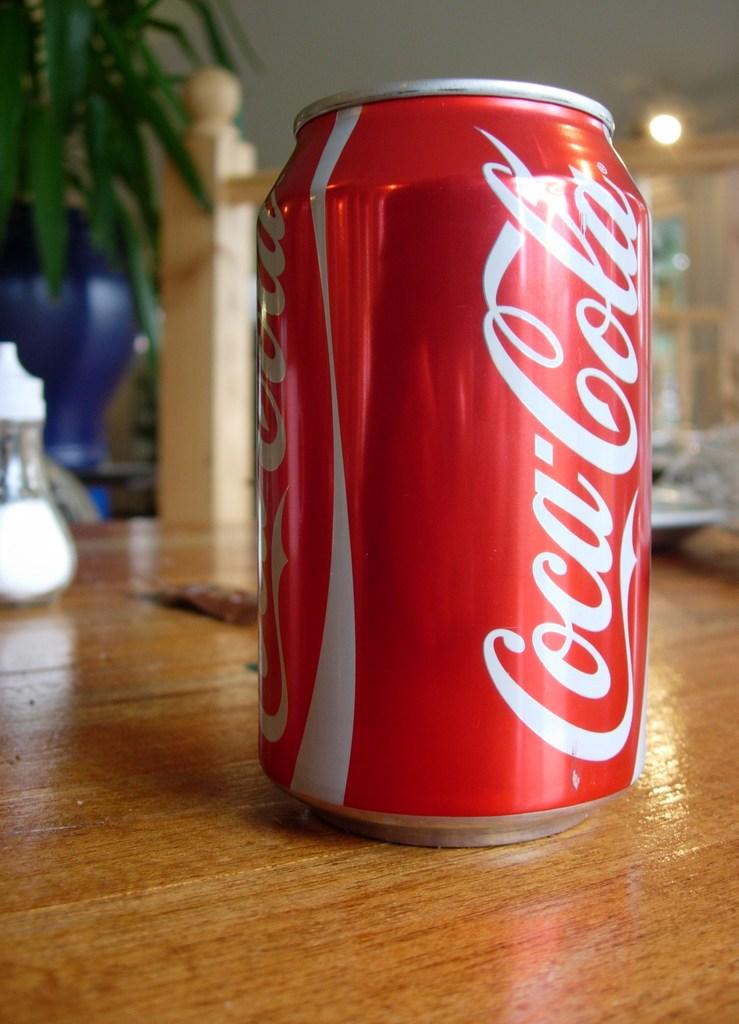What's in the can?
Your answer should be compact. Coca cola. Is this a can of pepsi?
Provide a short and direct response. No. 